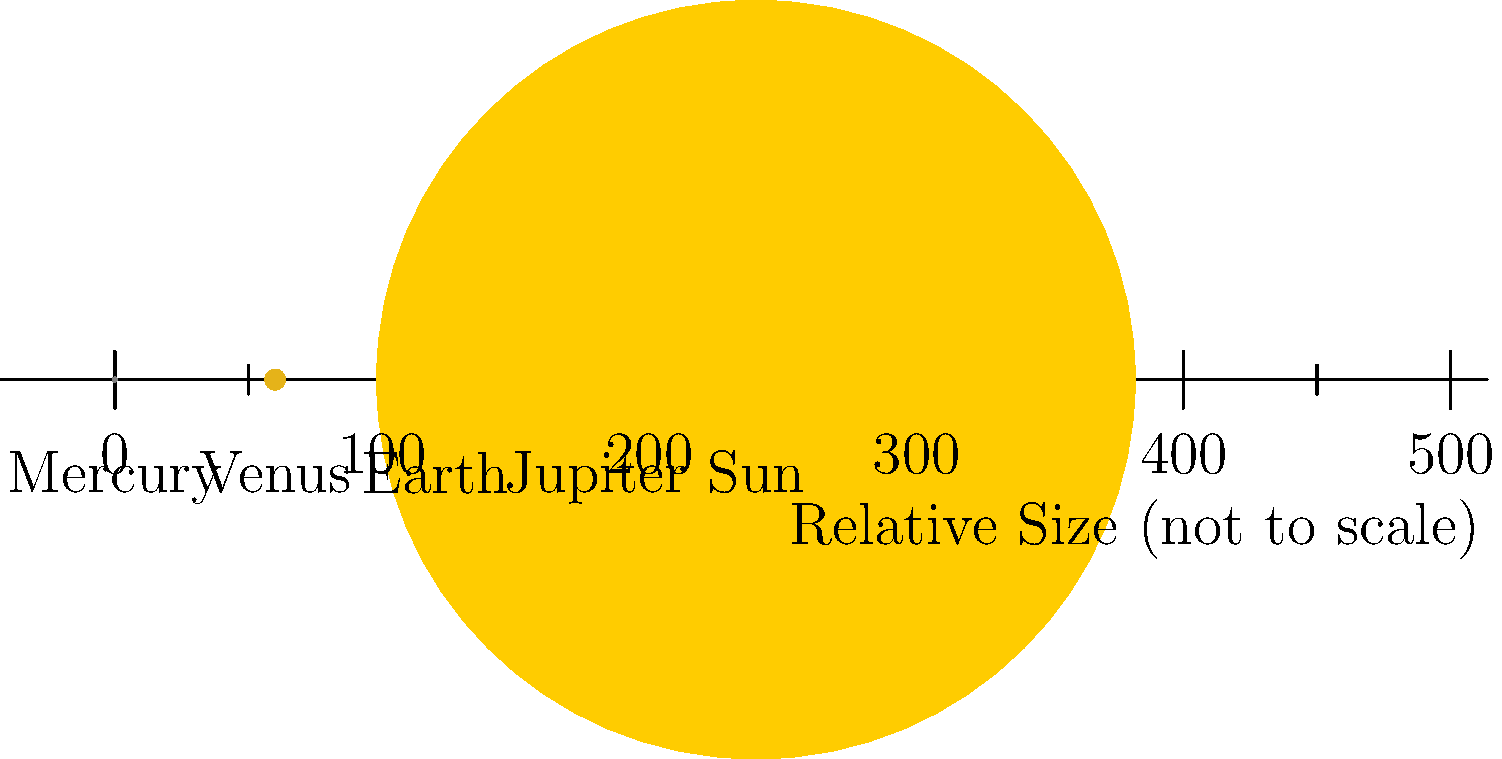Based on the relative sizes of celestial bodies shown in the image, which one is most likely to have the greatest impact on Earth's ecosystems through its gravitational influence, and how might this influence wildlife migration patterns? To answer this question, we need to consider the following steps:

1. Analyze the relative sizes:
   The image shows Mercury, Venus, Earth, Jupiter, and the Sun in order of increasing size.

2. Consider gravitational influence:
   Gravitational force is proportional to mass, which is related to size for celestial bodies.

3. Identify the largest body:
   The Sun is significantly larger than all the planets shown.

4. Understand the Sun's influence on Earth:
   a) The Sun's gravity keeps Earth in orbit.
   b) Solar radiation affects Earth's climate and seasons.

5. Connect solar influence to ecosystems:
   a) Seasons drive many ecological processes.
   b) Climate patterns affect habitat distributions.

6. Link to wildlife migration:
   a) Many species migrate based on seasonal changes.
   b) Examples include birds, marine animals, and insects.

7. Consider Jupiter's influence:
   While large, Jupiter's distance from Earth minimizes its direct impact on ecosystems.

Therefore, the Sun, being the largest body shown and closest to Earth (excluding Venus), has the most significant impact on Earth's ecosystems through its gravitational and radiative influence. This affects wildlife migration patterns by driving seasonal changes and climate patterns that many species rely on for their life cycles.
Answer: The Sun; it drives seasonal changes influencing migration. 